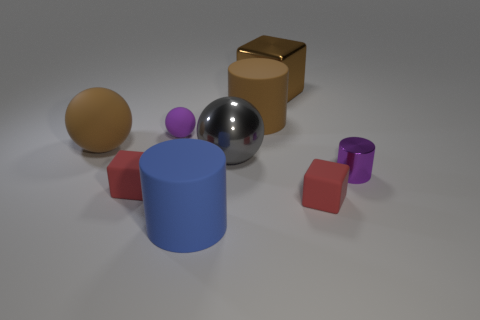There is a large matte object that is the same shape as the small purple rubber thing; what is its color?
Ensure brevity in your answer.  Brown. The brown metallic block has what size?
Ensure brevity in your answer.  Large. The small rubber object right of the metallic object that is behind the brown rubber ball is what color?
Make the answer very short. Red. How many shiny objects are left of the tiny purple shiny cylinder and in front of the metal block?
Offer a very short reply. 1. Is the number of green matte things greater than the number of small red blocks?
Offer a very short reply. No. What is the big brown cylinder made of?
Your answer should be very brief. Rubber. How many big brown balls are in front of the red thing that is right of the blue object?
Offer a terse response. 0. There is a large matte ball; is its color the same as the rubber cylinder that is behind the blue rubber thing?
Your answer should be very brief. Yes. There is a metallic block that is the same size as the brown ball; what color is it?
Offer a very short reply. Brown. Are there any other small things of the same shape as the blue matte thing?
Provide a succinct answer. Yes. 